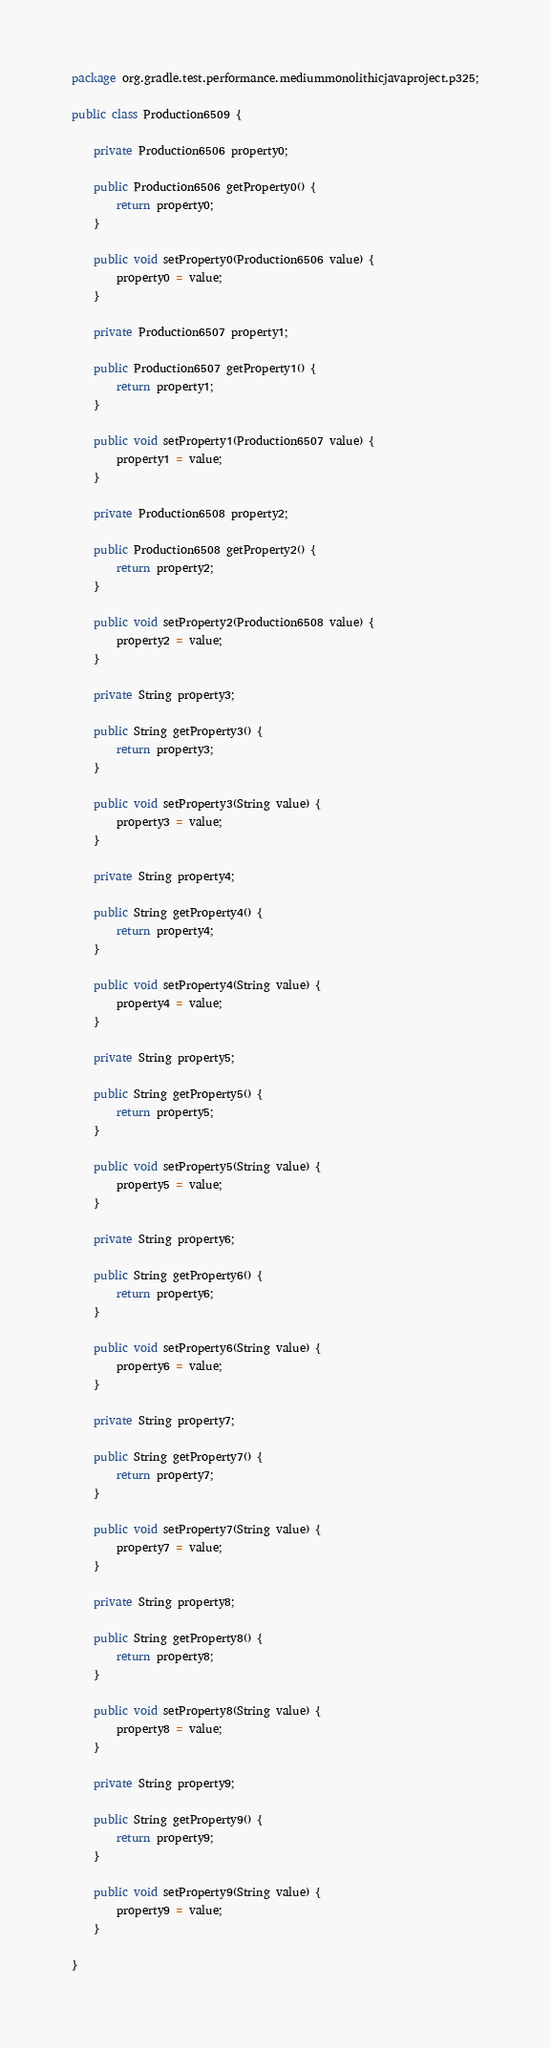Convert code to text. <code><loc_0><loc_0><loc_500><loc_500><_Java_>package org.gradle.test.performance.mediummonolithicjavaproject.p325;

public class Production6509 {        

    private Production6506 property0;

    public Production6506 getProperty0() {
        return property0;
    }

    public void setProperty0(Production6506 value) {
        property0 = value;
    }

    private Production6507 property1;

    public Production6507 getProperty1() {
        return property1;
    }

    public void setProperty1(Production6507 value) {
        property1 = value;
    }

    private Production6508 property2;

    public Production6508 getProperty2() {
        return property2;
    }

    public void setProperty2(Production6508 value) {
        property2 = value;
    }

    private String property3;

    public String getProperty3() {
        return property3;
    }

    public void setProperty3(String value) {
        property3 = value;
    }

    private String property4;

    public String getProperty4() {
        return property4;
    }

    public void setProperty4(String value) {
        property4 = value;
    }

    private String property5;

    public String getProperty5() {
        return property5;
    }

    public void setProperty5(String value) {
        property5 = value;
    }

    private String property6;

    public String getProperty6() {
        return property6;
    }

    public void setProperty6(String value) {
        property6 = value;
    }

    private String property7;

    public String getProperty7() {
        return property7;
    }

    public void setProperty7(String value) {
        property7 = value;
    }

    private String property8;

    public String getProperty8() {
        return property8;
    }

    public void setProperty8(String value) {
        property8 = value;
    }

    private String property9;

    public String getProperty9() {
        return property9;
    }

    public void setProperty9(String value) {
        property9 = value;
    }

}</code> 